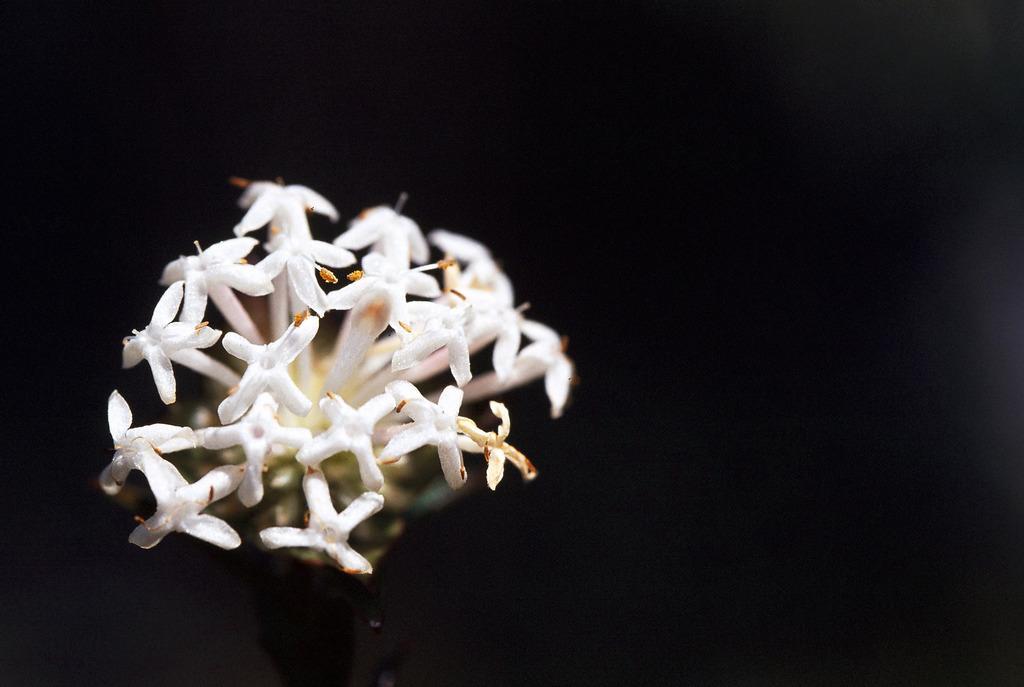Describe this image in one or two sentences. There are white color flowers. There is a black background. 